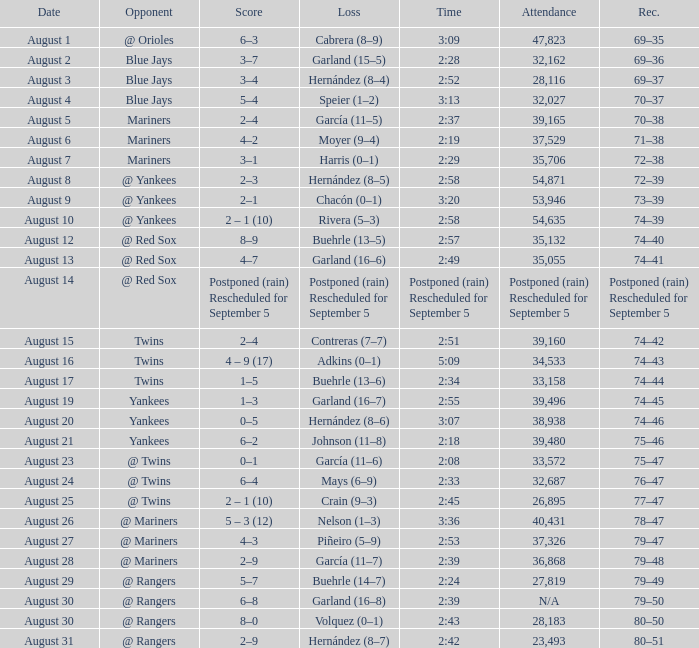Who lost with a time of 2:42? Hernández (8–7). 